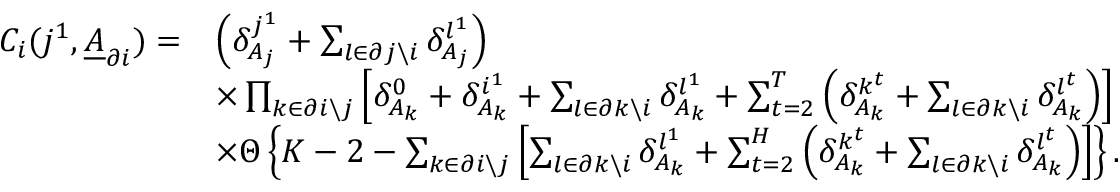<formula> <loc_0><loc_0><loc_500><loc_500>\begin{array} { r l } { C _ { i } ( j ^ { 1 } , \underline { A } _ { \partial i } ) = } & { \left ( \delta _ { A _ { j } } ^ { j ^ { 1 } } + \sum _ { l \in \partial j \ i } \delta _ { A _ { j } } ^ { l ^ { 1 } } \right ) } \\ & { \times \prod _ { k \in \partial i \ j } \left [ \delta _ { A _ { k } } ^ { 0 } + \delta _ { A _ { k } } ^ { i ^ { 1 } } + \sum _ { l \in \partial k \ i } \delta _ { A _ { k } } ^ { l ^ { 1 } } + \sum _ { t = 2 } ^ { T } \left ( \delta _ { A _ { k } } ^ { k ^ { t } } + \sum _ { l \in \partial k \ i } \delta _ { A _ { k } } ^ { l ^ { t } } \right ) \right ] } \\ & { \times \Theta \left \{ K - 2 - \sum _ { k \in \partial i \ j } \left [ \sum _ { l \in \partial k \ i } \delta _ { A _ { k } } ^ { l ^ { 1 } } + \sum _ { t = 2 } ^ { H } \left ( \delta _ { A _ { k } } ^ { k ^ { t } } + \sum _ { l \in \partial k \ i } \delta _ { A _ { k } } ^ { l ^ { t } } \right ) \right ] \right \} . } \end{array}</formula> 